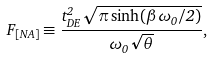Convert formula to latex. <formula><loc_0><loc_0><loc_500><loc_500>F _ { [ N A ] } \equiv \frac { t _ { D E } ^ { 2 } \sqrt { \pi \sinh ( \beta \omega _ { 0 } / 2 ) } } { \omega _ { 0 } \sqrt { \theta } } ,</formula> 